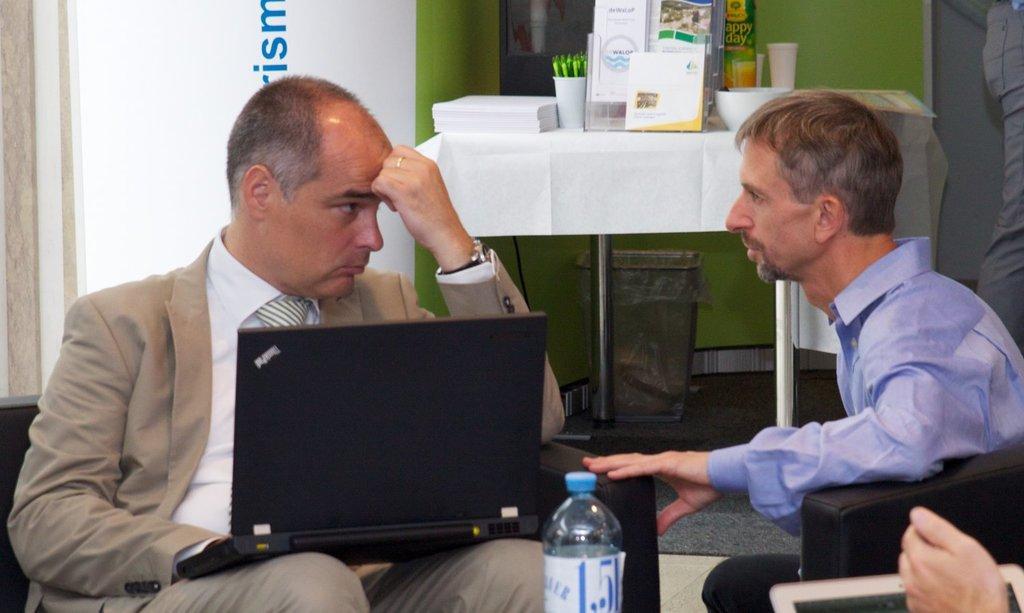Can you describe this image briefly? In this image there are three persons. On the left there is a person sitting on the chair holding a laptop. There is a table,bin in the room. At the background there is a wall colored in green. On the table there are paper,flower pot,book stand,bowl,cup. 